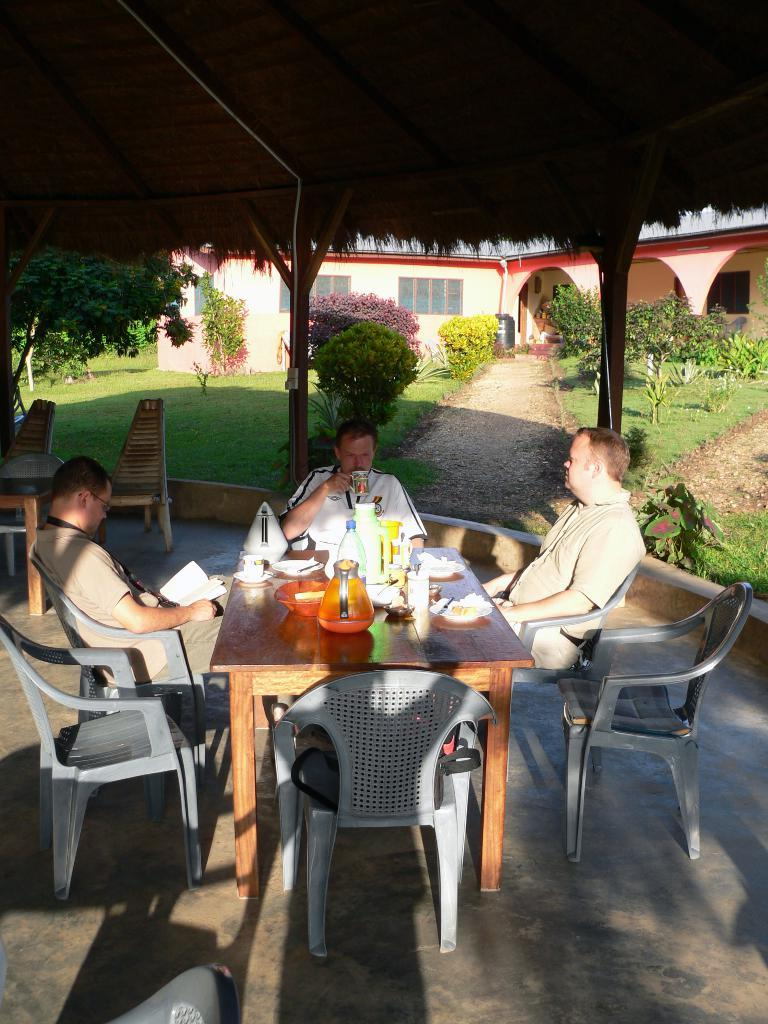How many people are seated in the image? There are three people seated on chairs in the image. What are two of the people doing in the image? One man is reading a book, and another man is drinking from a cup. What can be seen in the image besides the people and their activities? There are plants, a house, and a tree visible in the image. What type of company is being discussed by the people in the image? There is no indication in the image that the people are discussing any company or society; they are engaged in individual activities. 